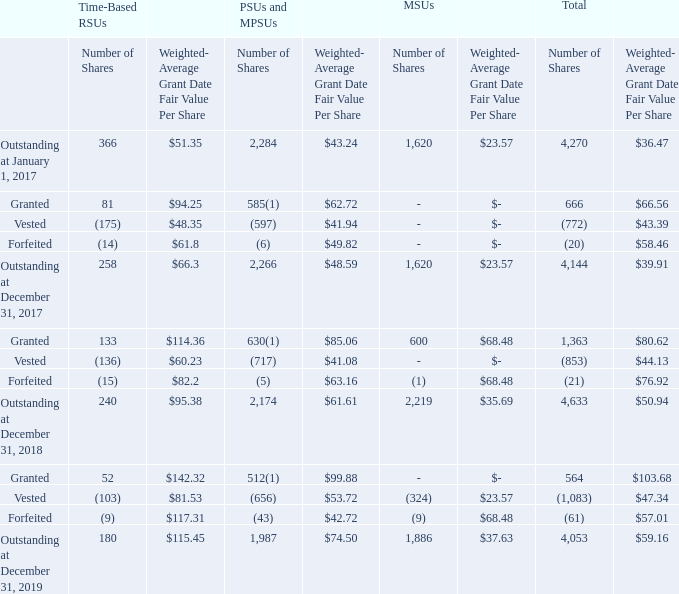RSUs
The Company’s RSUs include time-based RSUs, RSUs with performance conditions (“PSUs”), RSUs with market conditions (“MSUs”), and RSUs with both market and performance conditions (“MPSUs”). Vesting of awards with performance conditions or market conditions is subject to the achievement of pre-determined performance goals and the approval of such achievement by the Compensation Committee of the Board of Directors (the “Compensation Committee”). All awards include service conditions which require continued employment with the Company.
A summary of RSU activity is presented in the table below (in thousands, except per-share amounts):
(1) Amount reflects the number of awards that may ultimately be earned based on management’s probability assessment of the achievement of performance conditions at each reporting period.
The intrinsic value related to vested RSUs was $138.3 million, $90.0 million and $74.0 million for the years ended December 31, 2019, 2018 and 2017, respectively. As of December 31, 2019, the total intrinsic value of all outstanding RSUs was $679.5 million, based on the closing stock price of $178.02. As of December 31, 2019, unamortized compensation expense related to all outstanding RSUs was $100.1 million with a weighted-average remaining recognition period of approximately three years.
Cash proceeds from vested PSUs with a purchase price totaled $16.6 million and $10.6 million for the years ended December 31, 2019 and 2018, respectively. There were no proceeds for the year ended December 31, 2017.
What was the Weighted-Average Grant Date Fair Value Per Share for Time-Based RSUs and MSUs outstanding at January 1, 2017? 51.35, 23.57. How many shares of PSUs and MPSUs, and Time-Based RSUs does the company have Outstanding at December 31, 2018 respectively?
Answer scale should be: thousand. 2,174, 240. What was the intrinsic value related to vested RSUs for the year ended December 31, 2018? $90.0 million. What was the percentage change in Number of shares of PSUs and MPSUs Outstanding at December 31, 2017 to December 31, 2018?
Answer scale should be: percent. (2,174-2,266)/2,266
Answer: -4.06. From 2017 to 2019, for how many years was the intrinsic value related to vested RSUs more than $80 million? $138.3 million##$90.0 million
Answer: 2. At which point of time time were there the most total shares outstanding? 4,633>4,270>4,053>4,144
Answer: december 31, 2018. 